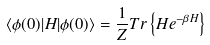<formula> <loc_0><loc_0><loc_500><loc_500>\langle \phi ( 0 ) | H | \phi ( 0 ) \rangle = \frac { 1 } { Z } T r \left \{ H e ^ { - \beta H } \right \}</formula> 